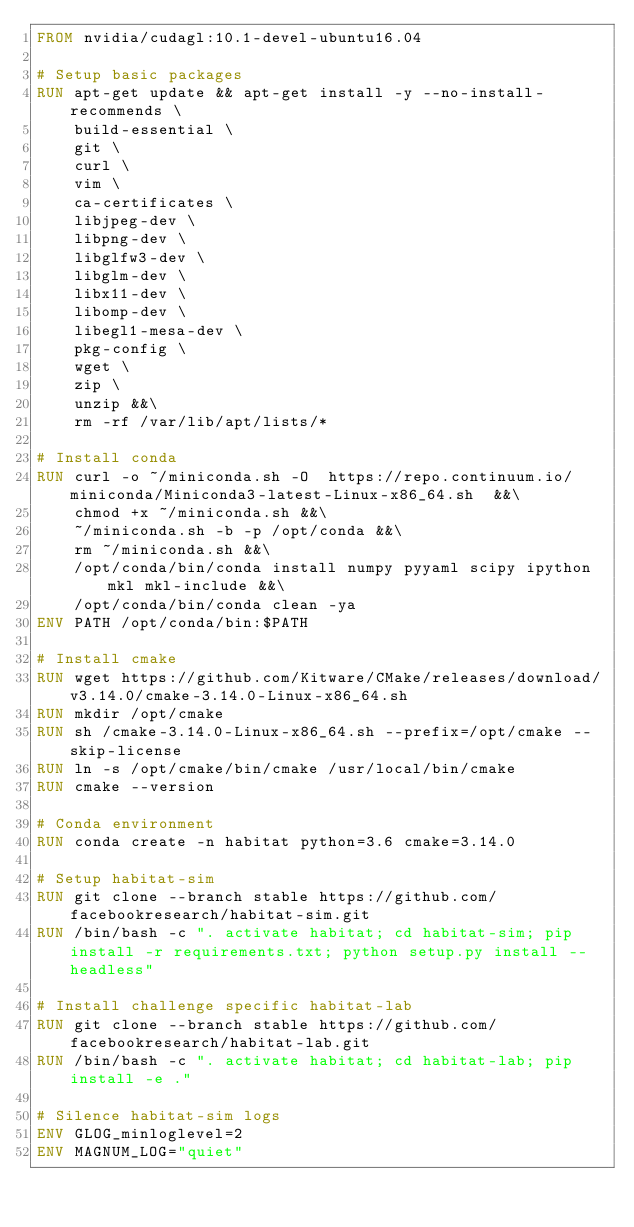<code> <loc_0><loc_0><loc_500><loc_500><_Dockerfile_>FROM nvidia/cudagl:10.1-devel-ubuntu16.04

# Setup basic packages
RUN apt-get update && apt-get install -y --no-install-recommends \
    build-essential \
    git \
    curl \
    vim \
    ca-certificates \
    libjpeg-dev \
    libpng-dev \
    libglfw3-dev \
    libglm-dev \
    libx11-dev \
    libomp-dev \
    libegl1-mesa-dev \
    pkg-config \
    wget \
    zip \
    unzip &&\
    rm -rf /var/lib/apt/lists/*

# Install conda
RUN curl -o ~/miniconda.sh -O  https://repo.continuum.io/miniconda/Miniconda3-latest-Linux-x86_64.sh  &&\
    chmod +x ~/miniconda.sh &&\
    ~/miniconda.sh -b -p /opt/conda &&\
    rm ~/miniconda.sh &&\
    /opt/conda/bin/conda install numpy pyyaml scipy ipython mkl mkl-include &&\
    /opt/conda/bin/conda clean -ya
ENV PATH /opt/conda/bin:$PATH

# Install cmake
RUN wget https://github.com/Kitware/CMake/releases/download/v3.14.0/cmake-3.14.0-Linux-x86_64.sh
RUN mkdir /opt/cmake
RUN sh /cmake-3.14.0-Linux-x86_64.sh --prefix=/opt/cmake --skip-license
RUN ln -s /opt/cmake/bin/cmake /usr/local/bin/cmake
RUN cmake --version

# Conda environment
RUN conda create -n habitat python=3.6 cmake=3.14.0

# Setup habitat-sim
RUN git clone --branch stable https://github.com/facebookresearch/habitat-sim.git
RUN /bin/bash -c ". activate habitat; cd habitat-sim; pip install -r requirements.txt; python setup.py install --headless"

# Install challenge specific habitat-lab
RUN git clone --branch stable https://github.com/facebookresearch/habitat-lab.git
RUN /bin/bash -c ". activate habitat; cd habitat-lab; pip install -e ."

# Silence habitat-sim logs
ENV GLOG_minloglevel=2
ENV MAGNUM_LOG="quiet"
</code> 